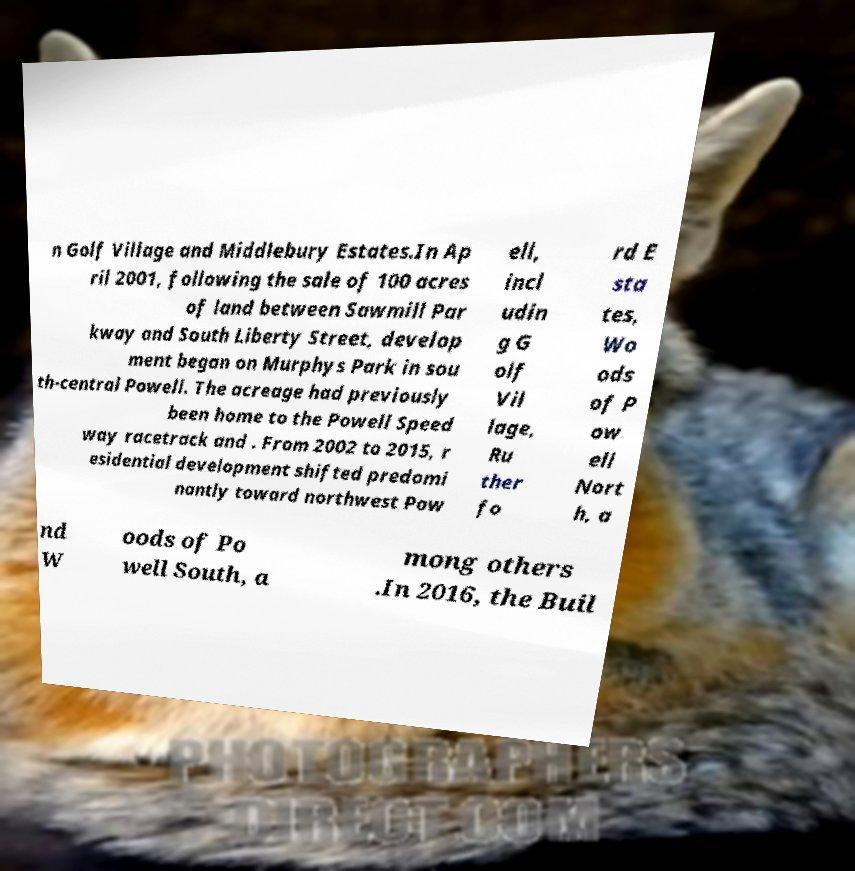What messages or text are displayed in this image? I need them in a readable, typed format. n Golf Village and Middlebury Estates.In Ap ril 2001, following the sale of 100 acres of land between Sawmill Par kway and South Liberty Street, develop ment began on Murphys Park in sou th-central Powell. The acreage had previously been home to the Powell Speed way racetrack and . From 2002 to 2015, r esidential development shifted predomi nantly toward northwest Pow ell, incl udin g G olf Vil lage, Ru ther fo rd E sta tes, Wo ods of P ow ell Nort h, a nd W oods of Po well South, a mong others .In 2016, the Buil 